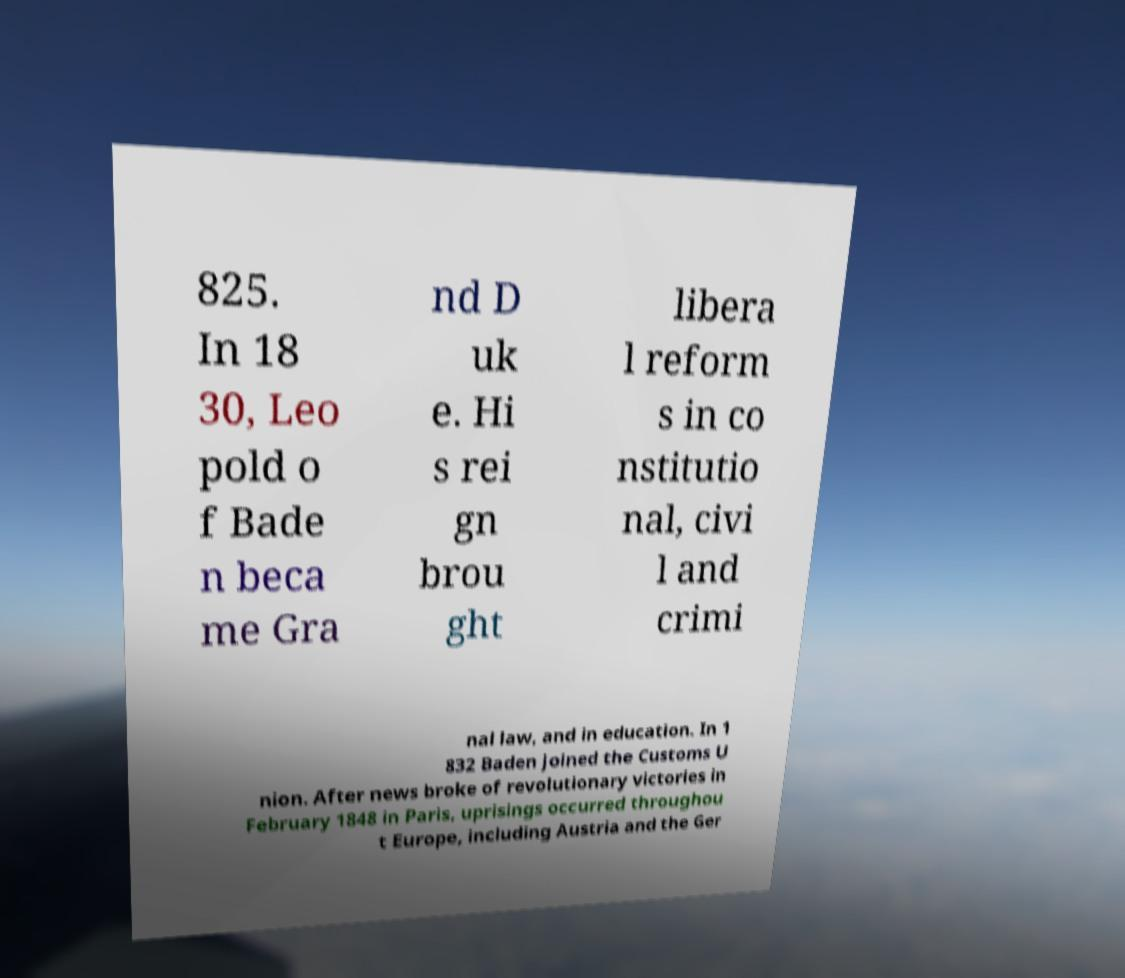I need the written content from this picture converted into text. Can you do that? 825. In 18 30, Leo pold o f Bade n beca me Gra nd D uk e. Hi s rei gn brou ght libera l reform s in co nstitutio nal, civi l and crimi nal law, and in education. In 1 832 Baden joined the Customs U nion. After news broke of revolutionary victories in February 1848 in Paris, uprisings occurred throughou t Europe, including Austria and the Ger 